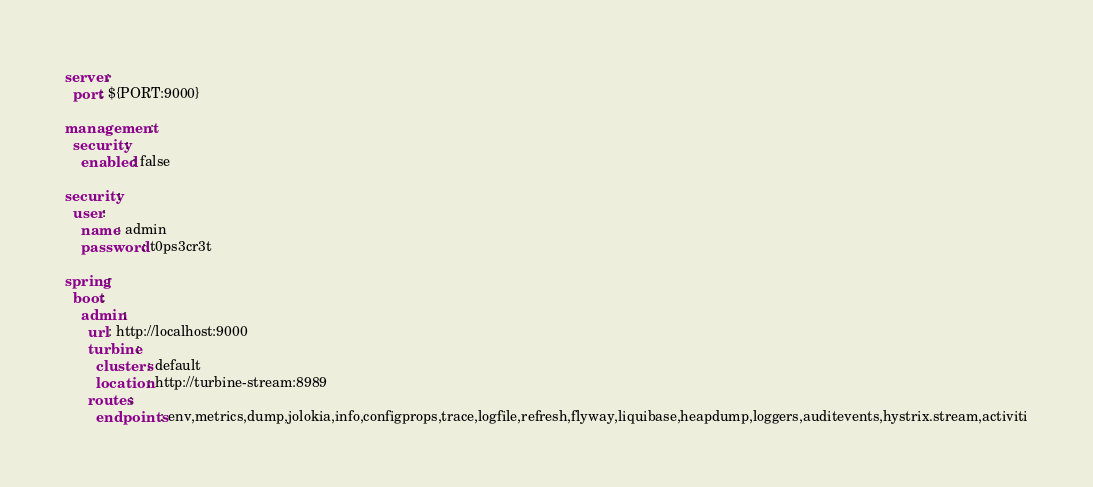<code> <loc_0><loc_0><loc_500><loc_500><_YAML_>server:
  port: ${PORT:9000}

management:
  security:
    enabled: false

security:
  user:
    name: admin
    password: t0ps3cr3t
    
spring:
  boot:
    admin:
      url: http://localhost:9000
      turbine:
        clusters: default
        location: http://turbine-stream:8989
      routes: 
        endpoints: env,metrics,dump,jolokia,info,configprops,trace,logfile,refresh,flyway,liquibase,heapdump,loggers,auditevents,hystrix.stream,activiti</code> 